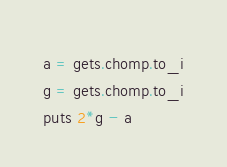<code> <loc_0><loc_0><loc_500><loc_500><_Ruby_>a = gets.chomp.to_i
g = gets.chomp.to_i
puts 2*g - a</code> 